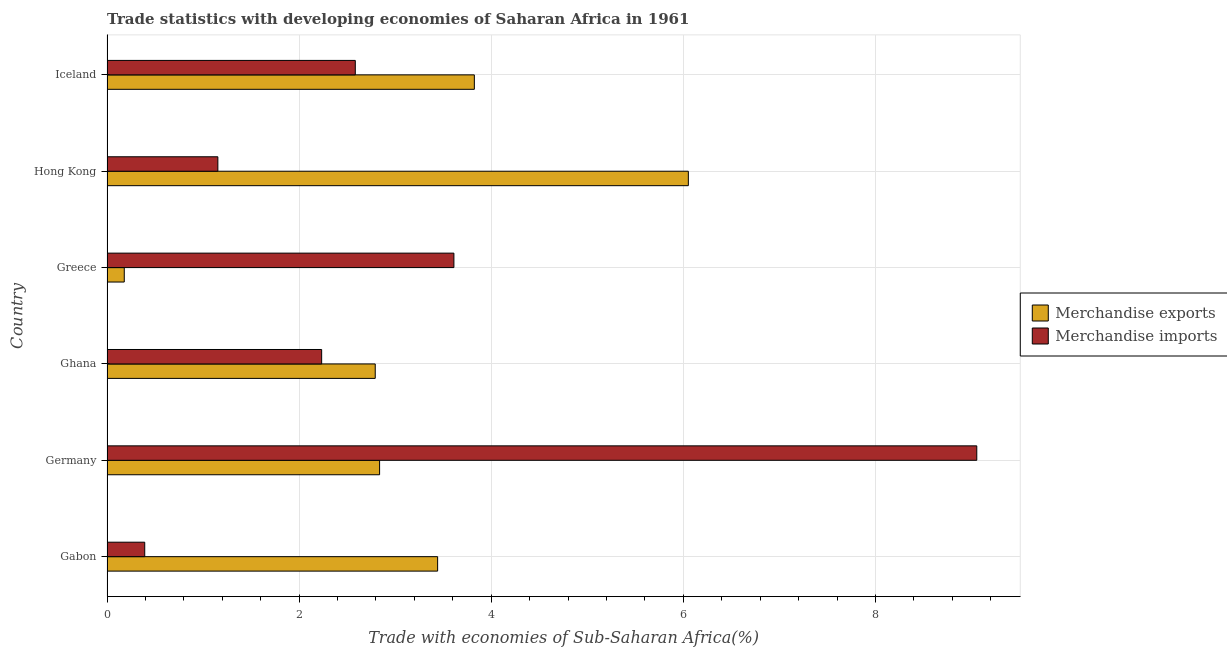Are the number of bars per tick equal to the number of legend labels?
Provide a short and direct response. Yes. How many bars are there on the 4th tick from the bottom?
Offer a very short reply. 2. What is the label of the 2nd group of bars from the top?
Ensure brevity in your answer.  Hong Kong. What is the merchandise imports in Iceland?
Make the answer very short. 2.58. Across all countries, what is the maximum merchandise exports?
Keep it short and to the point. 6.05. Across all countries, what is the minimum merchandise imports?
Offer a terse response. 0.39. In which country was the merchandise exports maximum?
Make the answer very short. Hong Kong. In which country was the merchandise exports minimum?
Give a very brief answer. Greece. What is the total merchandise exports in the graph?
Provide a short and direct response. 19.13. What is the difference between the merchandise imports in Germany and that in Greece?
Ensure brevity in your answer.  5.44. What is the difference between the merchandise exports in Iceland and the merchandise imports in Greece?
Provide a succinct answer. 0.21. What is the average merchandise imports per country?
Offer a very short reply. 3.17. What is the difference between the merchandise exports and merchandise imports in Iceland?
Your response must be concise. 1.24. What is the ratio of the merchandise exports in Germany to that in Hong Kong?
Offer a terse response. 0.47. Is the merchandise imports in Gabon less than that in Germany?
Your answer should be compact. Yes. Is the difference between the merchandise exports in Germany and Hong Kong greater than the difference between the merchandise imports in Germany and Hong Kong?
Ensure brevity in your answer.  No. What is the difference between the highest and the second highest merchandise imports?
Provide a succinct answer. 5.44. What is the difference between the highest and the lowest merchandise exports?
Offer a very short reply. 5.87. In how many countries, is the merchandise exports greater than the average merchandise exports taken over all countries?
Your answer should be very brief. 3. What does the 2nd bar from the top in Hong Kong represents?
Your response must be concise. Merchandise exports. How many bars are there?
Offer a very short reply. 12. Are all the bars in the graph horizontal?
Make the answer very short. Yes. Where does the legend appear in the graph?
Provide a short and direct response. Center right. How are the legend labels stacked?
Your response must be concise. Vertical. What is the title of the graph?
Your answer should be compact. Trade statistics with developing economies of Saharan Africa in 1961. Does "Rural" appear as one of the legend labels in the graph?
Offer a very short reply. No. What is the label or title of the X-axis?
Keep it short and to the point. Trade with economies of Sub-Saharan Africa(%). What is the label or title of the Y-axis?
Offer a very short reply. Country. What is the Trade with economies of Sub-Saharan Africa(%) in Merchandise exports in Gabon?
Your answer should be compact. 3.44. What is the Trade with economies of Sub-Saharan Africa(%) in Merchandise imports in Gabon?
Give a very brief answer. 0.39. What is the Trade with economies of Sub-Saharan Africa(%) of Merchandise exports in Germany?
Ensure brevity in your answer.  2.84. What is the Trade with economies of Sub-Saharan Africa(%) of Merchandise imports in Germany?
Your response must be concise. 9.06. What is the Trade with economies of Sub-Saharan Africa(%) in Merchandise exports in Ghana?
Make the answer very short. 2.79. What is the Trade with economies of Sub-Saharan Africa(%) of Merchandise imports in Ghana?
Offer a terse response. 2.23. What is the Trade with economies of Sub-Saharan Africa(%) of Merchandise exports in Greece?
Offer a terse response. 0.18. What is the Trade with economies of Sub-Saharan Africa(%) of Merchandise imports in Greece?
Offer a very short reply. 3.61. What is the Trade with economies of Sub-Saharan Africa(%) in Merchandise exports in Hong Kong?
Make the answer very short. 6.05. What is the Trade with economies of Sub-Saharan Africa(%) in Merchandise imports in Hong Kong?
Make the answer very short. 1.15. What is the Trade with economies of Sub-Saharan Africa(%) of Merchandise exports in Iceland?
Offer a very short reply. 3.82. What is the Trade with economies of Sub-Saharan Africa(%) in Merchandise imports in Iceland?
Provide a short and direct response. 2.58. Across all countries, what is the maximum Trade with economies of Sub-Saharan Africa(%) in Merchandise exports?
Your answer should be compact. 6.05. Across all countries, what is the maximum Trade with economies of Sub-Saharan Africa(%) of Merchandise imports?
Provide a succinct answer. 9.06. Across all countries, what is the minimum Trade with economies of Sub-Saharan Africa(%) in Merchandise exports?
Give a very brief answer. 0.18. Across all countries, what is the minimum Trade with economies of Sub-Saharan Africa(%) of Merchandise imports?
Provide a short and direct response. 0.39. What is the total Trade with economies of Sub-Saharan Africa(%) in Merchandise exports in the graph?
Give a very brief answer. 19.13. What is the total Trade with economies of Sub-Saharan Africa(%) of Merchandise imports in the graph?
Offer a very short reply. 19.03. What is the difference between the Trade with economies of Sub-Saharan Africa(%) of Merchandise exports in Gabon and that in Germany?
Make the answer very short. 0.6. What is the difference between the Trade with economies of Sub-Saharan Africa(%) of Merchandise imports in Gabon and that in Germany?
Give a very brief answer. -8.66. What is the difference between the Trade with economies of Sub-Saharan Africa(%) of Merchandise exports in Gabon and that in Ghana?
Keep it short and to the point. 0.65. What is the difference between the Trade with economies of Sub-Saharan Africa(%) in Merchandise imports in Gabon and that in Ghana?
Ensure brevity in your answer.  -1.84. What is the difference between the Trade with economies of Sub-Saharan Africa(%) in Merchandise exports in Gabon and that in Greece?
Keep it short and to the point. 3.26. What is the difference between the Trade with economies of Sub-Saharan Africa(%) in Merchandise imports in Gabon and that in Greece?
Ensure brevity in your answer.  -3.22. What is the difference between the Trade with economies of Sub-Saharan Africa(%) in Merchandise exports in Gabon and that in Hong Kong?
Ensure brevity in your answer.  -2.61. What is the difference between the Trade with economies of Sub-Saharan Africa(%) of Merchandise imports in Gabon and that in Hong Kong?
Make the answer very short. -0.76. What is the difference between the Trade with economies of Sub-Saharan Africa(%) in Merchandise exports in Gabon and that in Iceland?
Provide a short and direct response. -0.38. What is the difference between the Trade with economies of Sub-Saharan Africa(%) of Merchandise imports in Gabon and that in Iceland?
Provide a succinct answer. -2.19. What is the difference between the Trade with economies of Sub-Saharan Africa(%) of Merchandise exports in Germany and that in Ghana?
Keep it short and to the point. 0.05. What is the difference between the Trade with economies of Sub-Saharan Africa(%) in Merchandise imports in Germany and that in Ghana?
Offer a very short reply. 6.82. What is the difference between the Trade with economies of Sub-Saharan Africa(%) of Merchandise exports in Germany and that in Greece?
Your answer should be very brief. 2.66. What is the difference between the Trade with economies of Sub-Saharan Africa(%) in Merchandise imports in Germany and that in Greece?
Offer a very short reply. 5.44. What is the difference between the Trade with economies of Sub-Saharan Africa(%) in Merchandise exports in Germany and that in Hong Kong?
Provide a short and direct response. -3.21. What is the difference between the Trade with economies of Sub-Saharan Africa(%) in Merchandise imports in Germany and that in Hong Kong?
Give a very brief answer. 7.9. What is the difference between the Trade with economies of Sub-Saharan Africa(%) of Merchandise exports in Germany and that in Iceland?
Make the answer very short. -0.99. What is the difference between the Trade with economies of Sub-Saharan Africa(%) in Merchandise imports in Germany and that in Iceland?
Your answer should be compact. 6.47. What is the difference between the Trade with economies of Sub-Saharan Africa(%) of Merchandise exports in Ghana and that in Greece?
Ensure brevity in your answer.  2.61. What is the difference between the Trade with economies of Sub-Saharan Africa(%) in Merchandise imports in Ghana and that in Greece?
Your answer should be very brief. -1.38. What is the difference between the Trade with economies of Sub-Saharan Africa(%) of Merchandise exports in Ghana and that in Hong Kong?
Offer a terse response. -3.26. What is the difference between the Trade with economies of Sub-Saharan Africa(%) in Merchandise imports in Ghana and that in Hong Kong?
Keep it short and to the point. 1.08. What is the difference between the Trade with economies of Sub-Saharan Africa(%) in Merchandise exports in Ghana and that in Iceland?
Provide a short and direct response. -1.03. What is the difference between the Trade with economies of Sub-Saharan Africa(%) of Merchandise imports in Ghana and that in Iceland?
Offer a very short reply. -0.35. What is the difference between the Trade with economies of Sub-Saharan Africa(%) of Merchandise exports in Greece and that in Hong Kong?
Offer a terse response. -5.87. What is the difference between the Trade with economies of Sub-Saharan Africa(%) in Merchandise imports in Greece and that in Hong Kong?
Ensure brevity in your answer.  2.46. What is the difference between the Trade with economies of Sub-Saharan Africa(%) in Merchandise exports in Greece and that in Iceland?
Your answer should be very brief. -3.64. What is the difference between the Trade with economies of Sub-Saharan Africa(%) in Merchandise imports in Greece and that in Iceland?
Offer a terse response. 1.03. What is the difference between the Trade with economies of Sub-Saharan Africa(%) in Merchandise exports in Hong Kong and that in Iceland?
Give a very brief answer. 2.23. What is the difference between the Trade with economies of Sub-Saharan Africa(%) of Merchandise imports in Hong Kong and that in Iceland?
Provide a succinct answer. -1.43. What is the difference between the Trade with economies of Sub-Saharan Africa(%) in Merchandise exports in Gabon and the Trade with economies of Sub-Saharan Africa(%) in Merchandise imports in Germany?
Provide a succinct answer. -5.61. What is the difference between the Trade with economies of Sub-Saharan Africa(%) of Merchandise exports in Gabon and the Trade with economies of Sub-Saharan Africa(%) of Merchandise imports in Ghana?
Offer a terse response. 1.21. What is the difference between the Trade with economies of Sub-Saharan Africa(%) of Merchandise exports in Gabon and the Trade with economies of Sub-Saharan Africa(%) of Merchandise imports in Greece?
Make the answer very short. -0.17. What is the difference between the Trade with economies of Sub-Saharan Africa(%) in Merchandise exports in Gabon and the Trade with economies of Sub-Saharan Africa(%) in Merchandise imports in Hong Kong?
Your answer should be compact. 2.29. What is the difference between the Trade with economies of Sub-Saharan Africa(%) of Merchandise exports in Gabon and the Trade with economies of Sub-Saharan Africa(%) of Merchandise imports in Iceland?
Provide a short and direct response. 0.86. What is the difference between the Trade with economies of Sub-Saharan Africa(%) in Merchandise exports in Germany and the Trade with economies of Sub-Saharan Africa(%) in Merchandise imports in Ghana?
Your response must be concise. 0.6. What is the difference between the Trade with economies of Sub-Saharan Africa(%) in Merchandise exports in Germany and the Trade with economies of Sub-Saharan Africa(%) in Merchandise imports in Greece?
Ensure brevity in your answer.  -0.77. What is the difference between the Trade with economies of Sub-Saharan Africa(%) of Merchandise exports in Germany and the Trade with economies of Sub-Saharan Africa(%) of Merchandise imports in Hong Kong?
Provide a succinct answer. 1.68. What is the difference between the Trade with economies of Sub-Saharan Africa(%) in Merchandise exports in Germany and the Trade with economies of Sub-Saharan Africa(%) in Merchandise imports in Iceland?
Make the answer very short. 0.25. What is the difference between the Trade with economies of Sub-Saharan Africa(%) in Merchandise exports in Ghana and the Trade with economies of Sub-Saharan Africa(%) in Merchandise imports in Greece?
Your response must be concise. -0.82. What is the difference between the Trade with economies of Sub-Saharan Africa(%) in Merchandise exports in Ghana and the Trade with economies of Sub-Saharan Africa(%) in Merchandise imports in Hong Kong?
Provide a succinct answer. 1.64. What is the difference between the Trade with economies of Sub-Saharan Africa(%) of Merchandise exports in Ghana and the Trade with economies of Sub-Saharan Africa(%) of Merchandise imports in Iceland?
Offer a terse response. 0.21. What is the difference between the Trade with economies of Sub-Saharan Africa(%) of Merchandise exports in Greece and the Trade with economies of Sub-Saharan Africa(%) of Merchandise imports in Hong Kong?
Your response must be concise. -0.97. What is the difference between the Trade with economies of Sub-Saharan Africa(%) in Merchandise exports in Greece and the Trade with economies of Sub-Saharan Africa(%) in Merchandise imports in Iceland?
Make the answer very short. -2.41. What is the difference between the Trade with economies of Sub-Saharan Africa(%) of Merchandise exports in Hong Kong and the Trade with economies of Sub-Saharan Africa(%) of Merchandise imports in Iceland?
Offer a very short reply. 3.47. What is the average Trade with economies of Sub-Saharan Africa(%) in Merchandise exports per country?
Provide a short and direct response. 3.19. What is the average Trade with economies of Sub-Saharan Africa(%) of Merchandise imports per country?
Give a very brief answer. 3.17. What is the difference between the Trade with economies of Sub-Saharan Africa(%) of Merchandise exports and Trade with economies of Sub-Saharan Africa(%) of Merchandise imports in Gabon?
Provide a succinct answer. 3.05. What is the difference between the Trade with economies of Sub-Saharan Africa(%) of Merchandise exports and Trade with economies of Sub-Saharan Africa(%) of Merchandise imports in Germany?
Offer a very short reply. -6.22. What is the difference between the Trade with economies of Sub-Saharan Africa(%) in Merchandise exports and Trade with economies of Sub-Saharan Africa(%) in Merchandise imports in Ghana?
Ensure brevity in your answer.  0.56. What is the difference between the Trade with economies of Sub-Saharan Africa(%) in Merchandise exports and Trade with economies of Sub-Saharan Africa(%) in Merchandise imports in Greece?
Give a very brief answer. -3.43. What is the difference between the Trade with economies of Sub-Saharan Africa(%) in Merchandise exports and Trade with economies of Sub-Saharan Africa(%) in Merchandise imports in Hong Kong?
Give a very brief answer. 4.9. What is the difference between the Trade with economies of Sub-Saharan Africa(%) of Merchandise exports and Trade with economies of Sub-Saharan Africa(%) of Merchandise imports in Iceland?
Provide a succinct answer. 1.24. What is the ratio of the Trade with economies of Sub-Saharan Africa(%) in Merchandise exports in Gabon to that in Germany?
Provide a succinct answer. 1.21. What is the ratio of the Trade with economies of Sub-Saharan Africa(%) of Merchandise imports in Gabon to that in Germany?
Your response must be concise. 0.04. What is the ratio of the Trade with economies of Sub-Saharan Africa(%) of Merchandise exports in Gabon to that in Ghana?
Offer a terse response. 1.23. What is the ratio of the Trade with economies of Sub-Saharan Africa(%) of Merchandise imports in Gabon to that in Ghana?
Offer a terse response. 0.18. What is the ratio of the Trade with economies of Sub-Saharan Africa(%) of Merchandise exports in Gabon to that in Greece?
Keep it short and to the point. 19.15. What is the ratio of the Trade with economies of Sub-Saharan Africa(%) in Merchandise imports in Gabon to that in Greece?
Your answer should be very brief. 0.11. What is the ratio of the Trade with economies of Sub-Saharan Africa(%) in Merchandise exports in Gabon to that in Hong Kong?
Ensure brevity in your answer.  0.57. What is the ratio of the Trade with economies of Sub-Saharan Africa(%) of Merchandise imports in Gabon to that in Hong Kong?
Make the answer very short. 0.34. What is the ratio of the Trade with economies of Sub-Saharan Africa(%) in Merchandise imports in Gabon to that in Iceland?
Provide a succinct answer. 0.15. What is the ratio of the Trade with economies of Sub-Saharan Africa(%) in Merchandise exports in Germany to that in Ghana?
Make the answer very short. 1.02. What is the ratio of the Trade with economies of Sub-Saharan Africa(%) in Merchandise imports in Germany to that in Ghana?
Make the answer very short. 4.05. What is the ratio of the Trade with economies of Sub-Saharan Africa(%) in Merchandise exports in Germany to that in Greece?
Make the answer very short. 15.79. What is the ratio of the Trade with economies of Sub-Saharan Africa(%) of Merchandise imports in Germany to that in Greece?
Your answer should be very brief. 2.51. What is the ratio of the Trade with economies of Sub-Saharan Africa(%) of Merchandise exports in Germany to that in Hong Kong?
Ensure brevity in your answer.  0.47. What is the ratio of the Trade with economies of Sub-Saharan Africa(%) of Merchandise imports in Germany to that in Hong Kong?
Keep it short and to the point. 7.85. What is the ratio of the Trade with economies of Sub-Saharan Africa(%) of Merchandise exports in Germany to that in Iceland?
Make the answer very short. 0.74. What is the ratio of the Trade with economies of Sub-Saharan Africa(%) in Merchandise imports in Germany to that in Iceland?
Make the answer very short. 3.5. What is the ratio of the Trade with economies of Sub-Saharan Africa(%) of Merchandise exports in Ghana to that in Greece?
Your response must be concise. 15.53. What is the ratio of the Trade with economies of Sub-Saharan Africa(%) of Merchandise imports in Ghana to that in Greece?
Provide a succinct answer. 0.62. What is the ratio of the Trade with economies of Sub-Saharan Africa(%) in Merchandise exports in Ghana to that in Hong Kong?
Provide a short and direct response. 0.46. What is the ratio of the Trade with economies of Sub-Saharan Africa(%) in Merchandise imports in Ghana to that in Hong Kong?
Offer a very short reply. 1.94. What is the ratio of the Trade with economies of Sub-Saharan Africa(%) in Merchandise exports in Ghana to that in Iceland?
Keep it short and to the point. 0.73. What is the ratio of the Trade with economies of Sub-Saharan Africa(%) of Merchandise imports in Ghana to that in Iceland?
Your response must be concise. 0.86. What is the ratio of the Trade with economies of Sub-Saharan Africa(%) of Merchandise exports in Greece to that in Hong Kong?
Provide a succinct answer. 0.03. What is the ratio of the Trade with economies of Sub-Saharan Africa(%) of Merchandise imports in Greece to that in Hong Kong?
Provide a succinct answer. 3.13. What is the ratio of the Trade with economies of Sub-Saharan Africa(%) of Merchandise exports in Greece to that in Iceland?
Your response must be concise. 0.05. What is the ratio of the Trade with economies of Sub-Saharan Africa(%) in Merchandise imports in Greece to that in Iceland?
Offer a very short reply. 1.4. What is the ratio of the Trade with economies of Sub-Saharan Africa(%) of Merchandise exports in Hong Kong to that in Iceland?
Keep it short and to the point. 1.58. What is the ratio of the Trade with economies of Sub-Saharan Africa(%) of Merchandise imports in Hong Kong to that in Iceland?
Your answer should be compact. 0.45. What is the difference between the highest and the second highest Trade with economies of Sub-Saharan Africa(%) in Merchandise exports?
Your answer should be very brief. 2.23. What is the difference between the highest and the second highest Trade with economies of Sub-Saharan Africa(%) in Merchandise imports?
Provide a succinct answer. 5.44. What is the difference between the highest and the lowest Trade with economies of Sub-Saharan Africa(%) in Merchandise exports?
Ensure brevity in your answer.  5.87. What is the difference between the highest and the lowest Trade with economies of Sub-Saharan Africa(%) of Merchandise imports?
Make the answer very short. 8.66. 